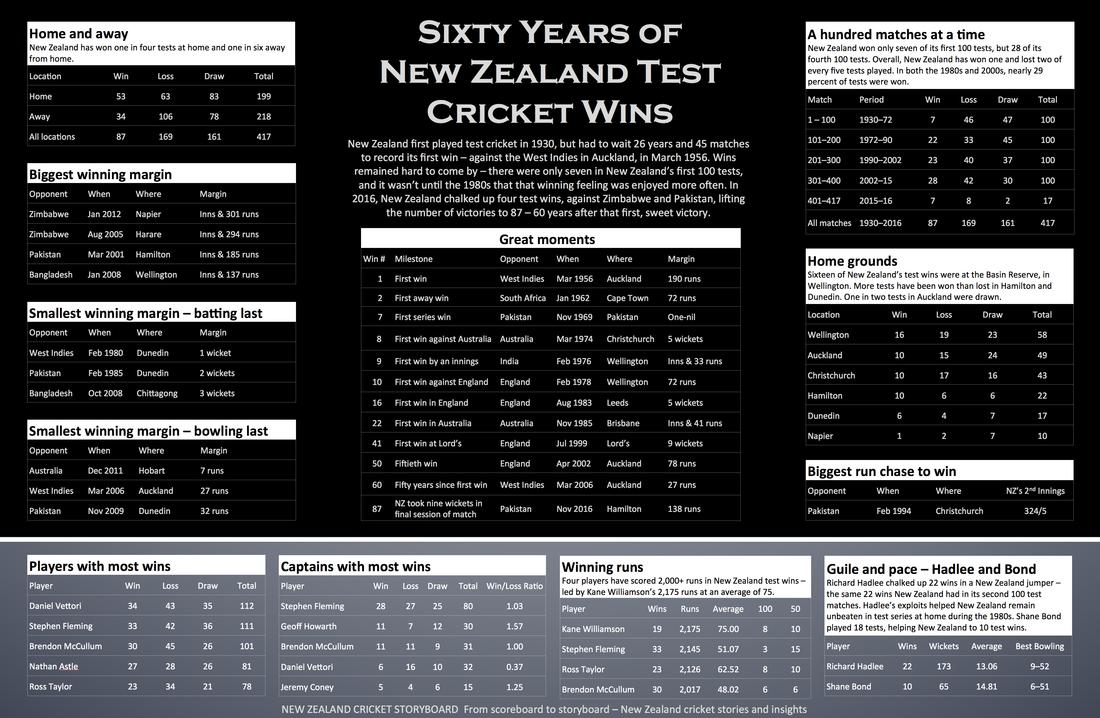List a handful of essential elements in this visual. During New Zealand's most significant moments, Australia served as its opponent on two occasions. During New Zealand's greatest moments, England served as the opponent four times. During New Zealand's most significant victories, Auckland served as the host city three times. New Zealand has the highest running margin against Zimbabwe. 